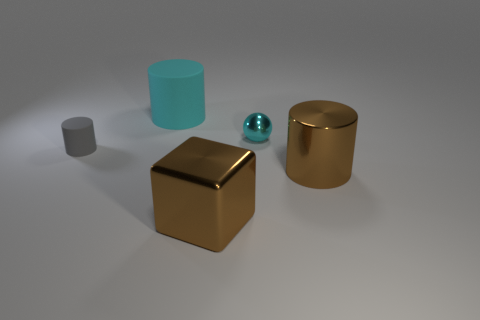Add 3 matte objects. How many objects exist? 8 Subtract all cylinders. How many objects are left? 2 Add 3 brown metallic objects. How many brown metallic objects exist? 5 Subtract 0 yellow cylinders. How many objects are left? 5 Subtract all brown cylinders. Subtract all small metallic spheres. How many objects are left? 3 Add 4 large shiny things. How many large shiny things are left? 6 